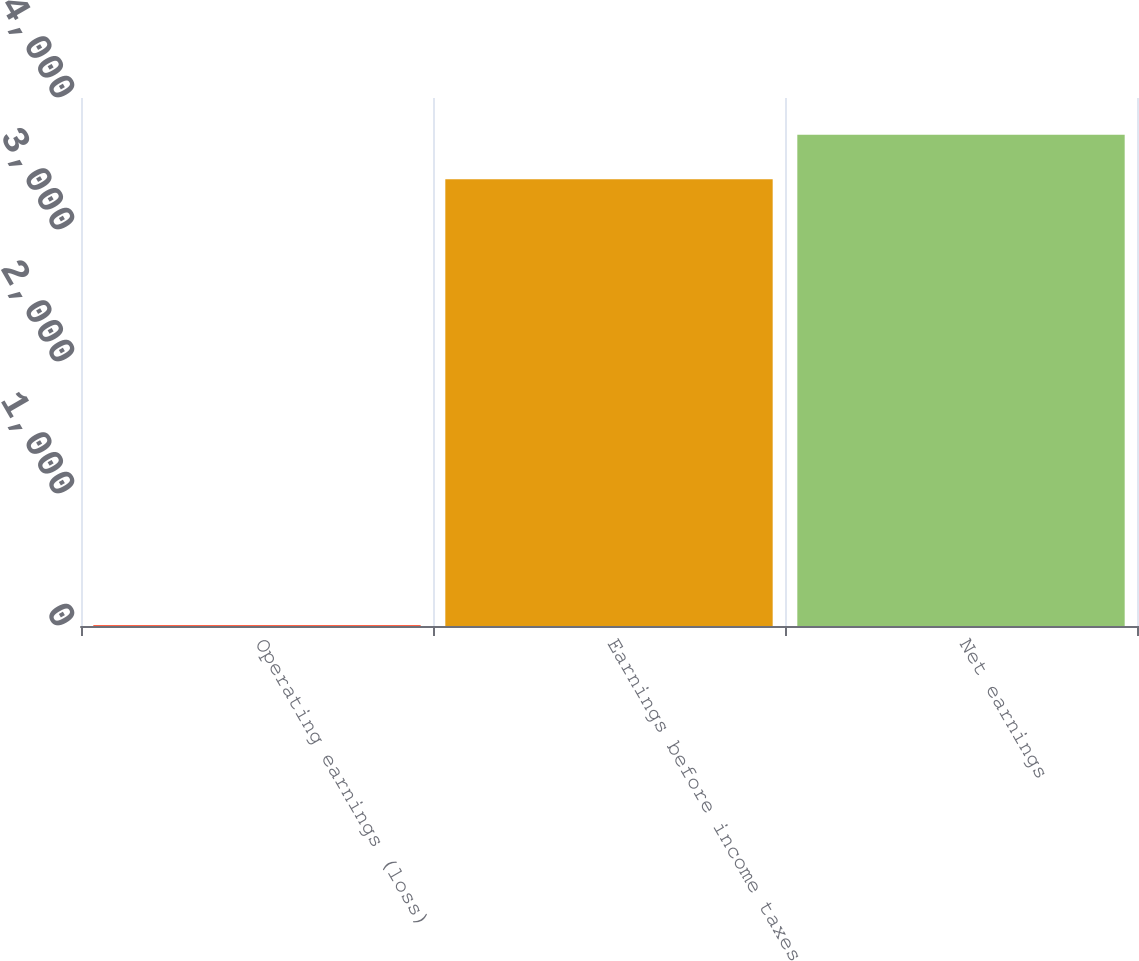Convert chart. <chart><loc_0><loc_0><loc_500><loc_500><bar_chart><fcel>Operating earnings (loss)<fcel>Earnings before income taxes<fcel>Net earnings<nl><fcel>7.3<fcel>3383.7<fcel>3721.34<nl></chart> 